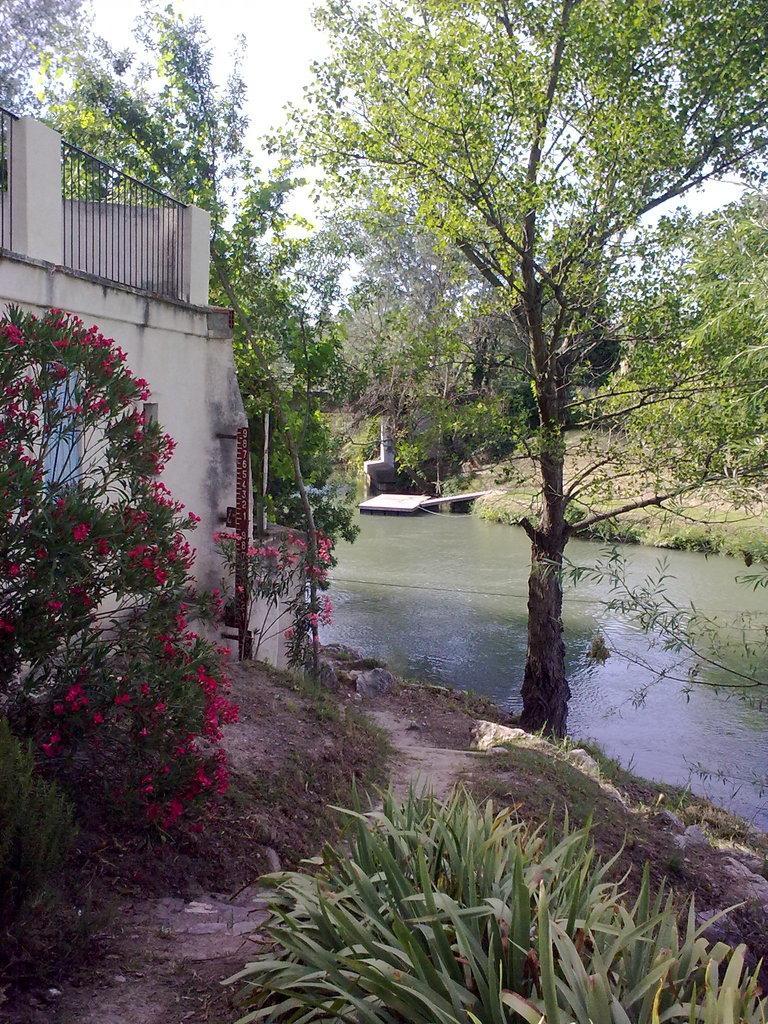Describe this image in one or two sentences. At the bottom of the image, we can see planets on the land. There is a railing and wall on the left side of the image. Background of the image, we can see a pond and trees. At the top of the image, we can see the sky. 